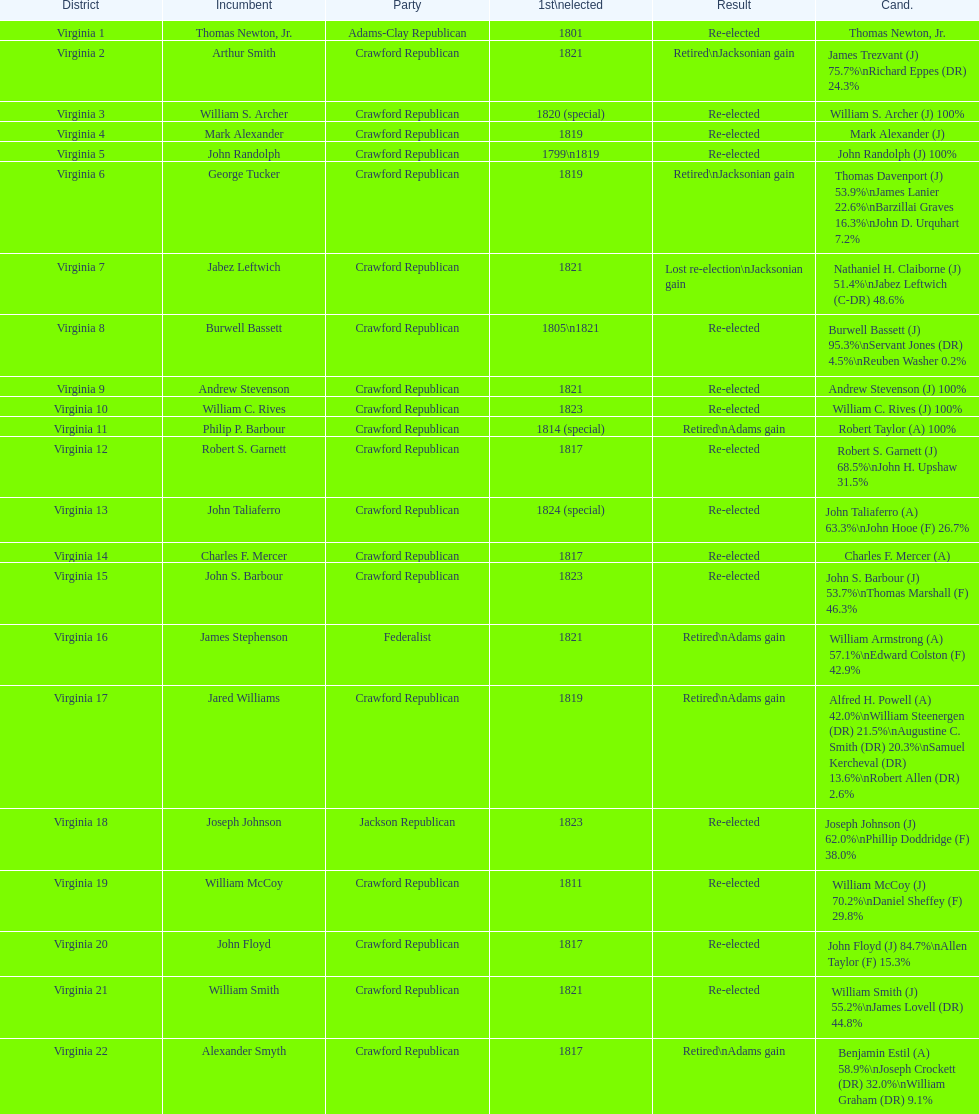What is the last party on this chart? Crawford Republican. 